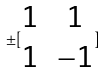<formula> <loc_0><loc_0><loc_500><loc_500>\pm [ \begin{matrix} 1 & 1 \\ 1 & - 1 \end{matrix} ]</formula> 